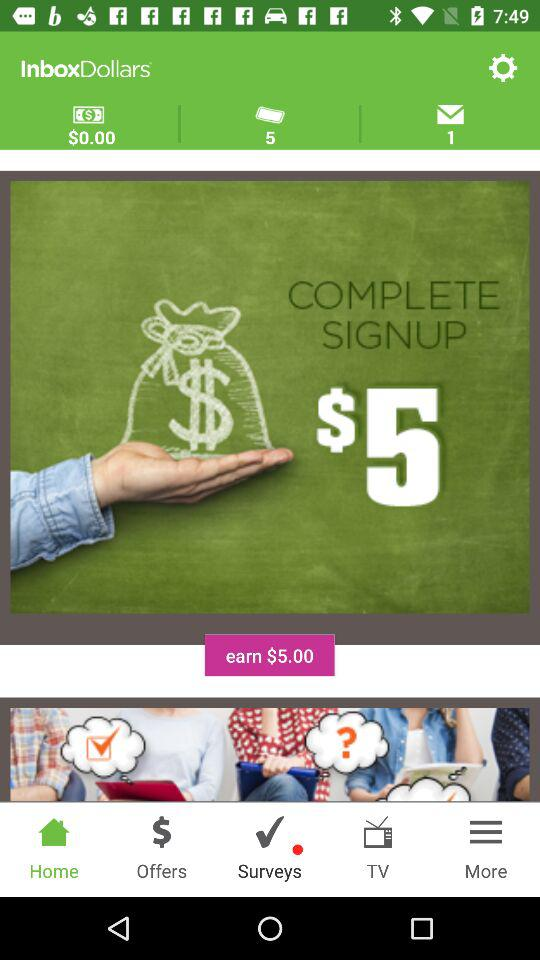Which is the selected tab? The selected tab is "Home". 